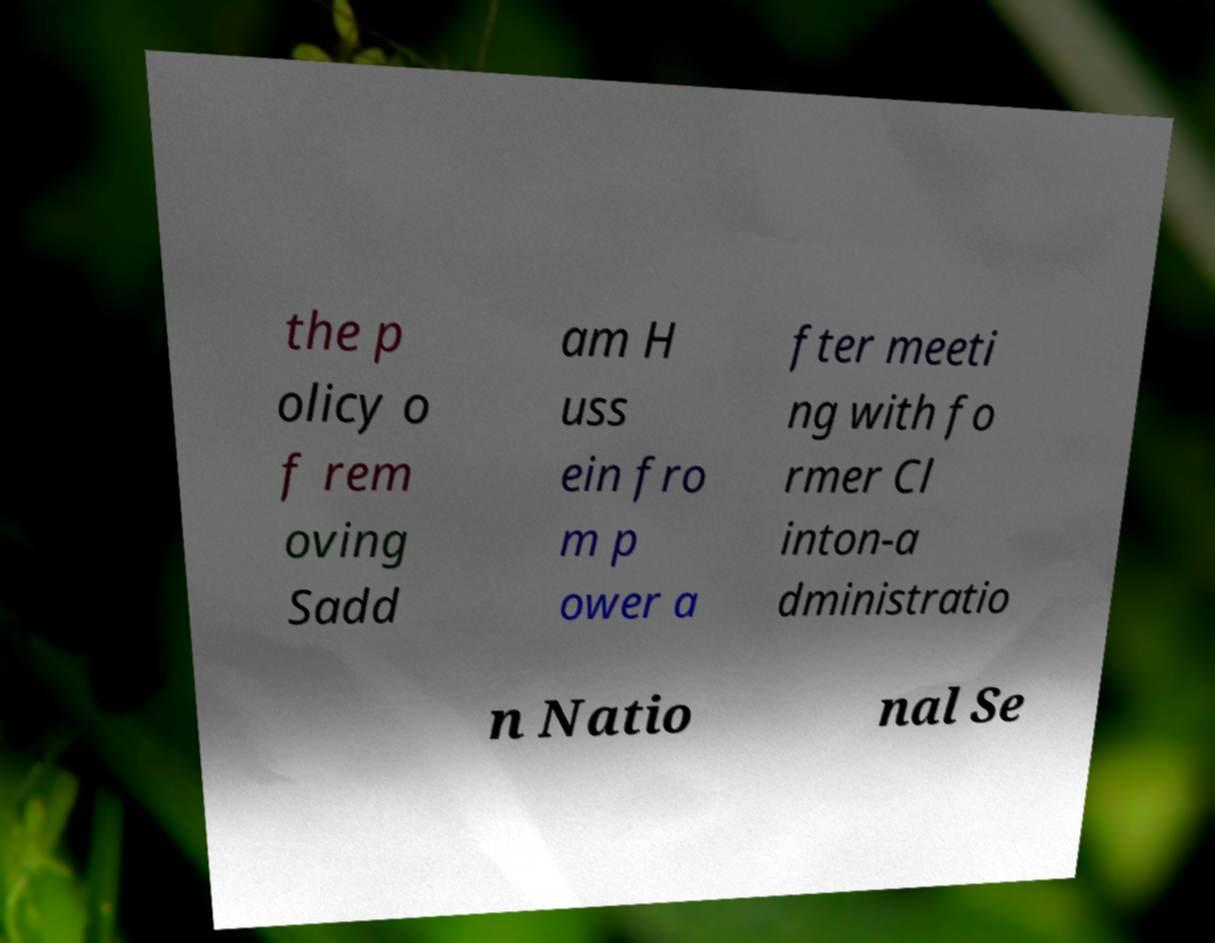What messages or text are displayed in this image? I need them in a readable, typed format. the p olicy o f rem oving Sadd am H uss ein fro m p ower a fter meeti ng with fo rmer Cl inton-a dministratio n Natio nal Se 